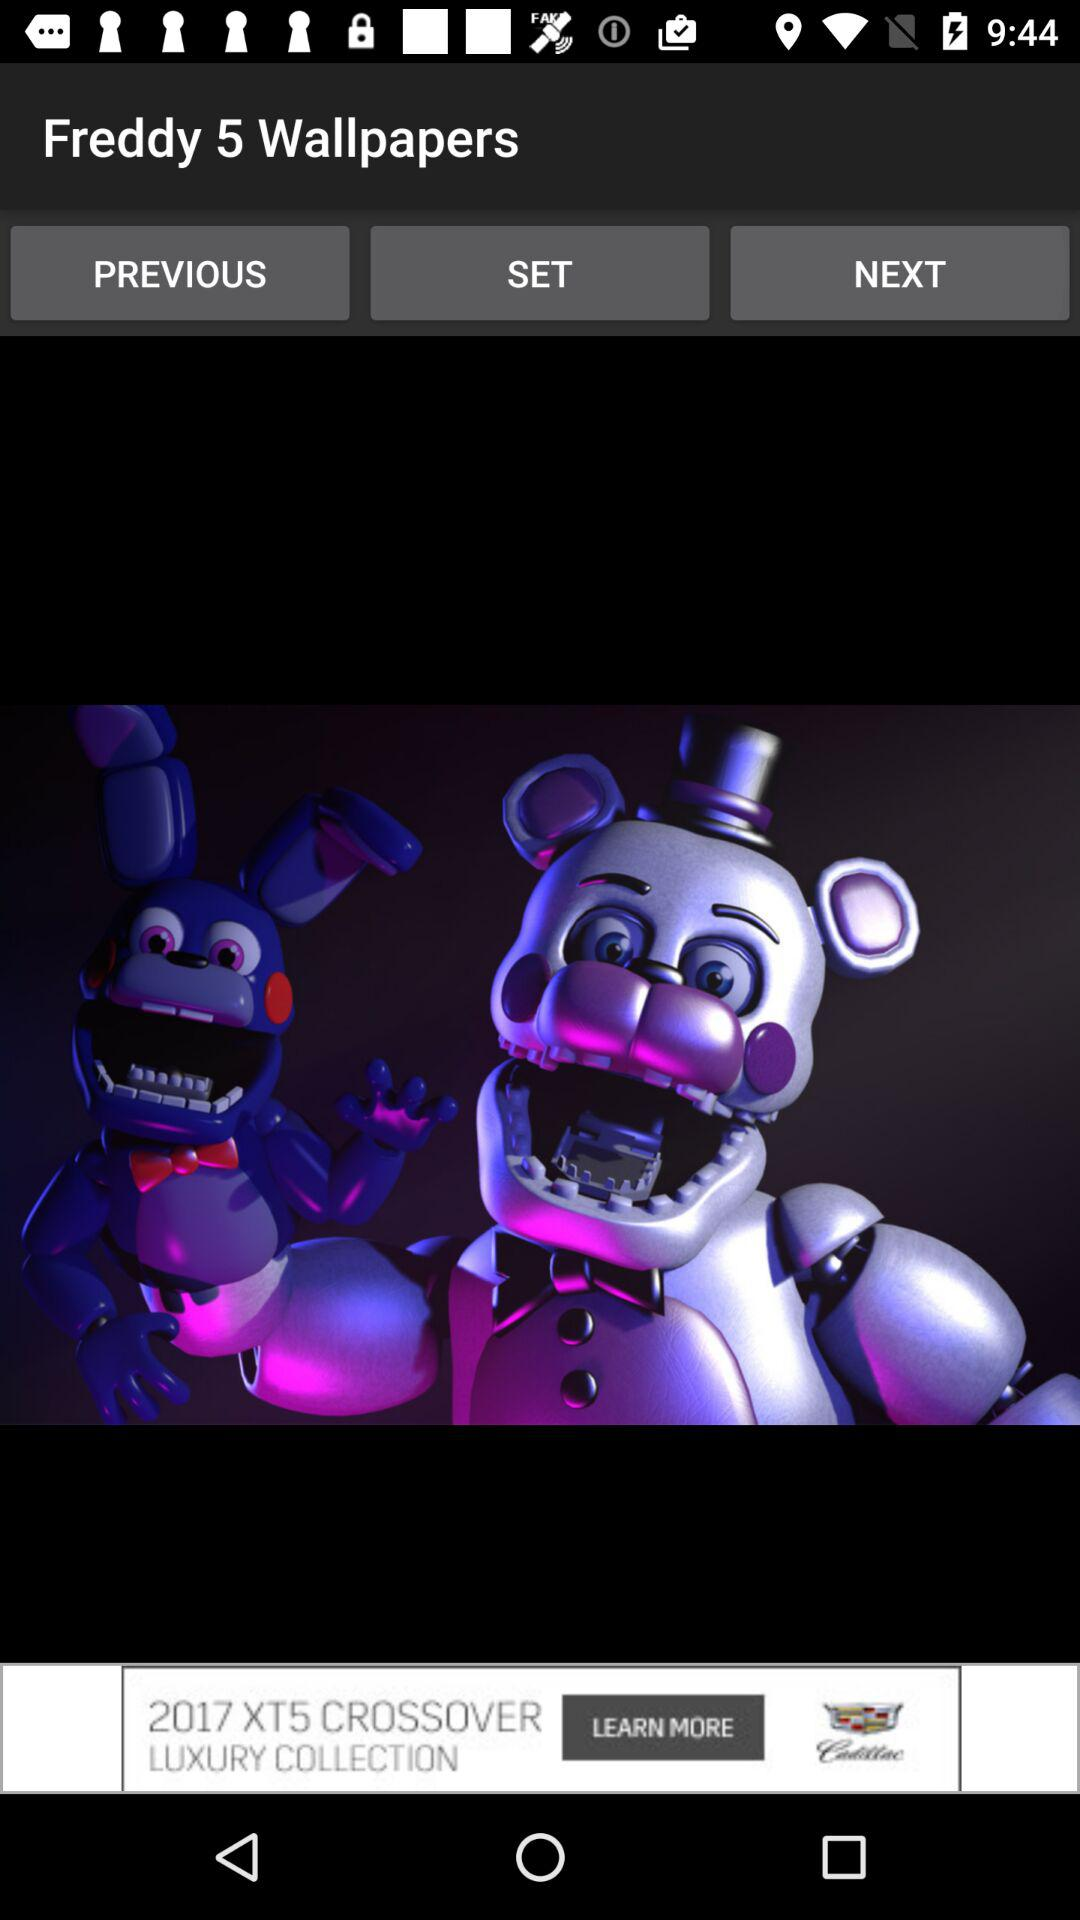What is the application name? The application name is "Freddy 5 Wallpapers". 